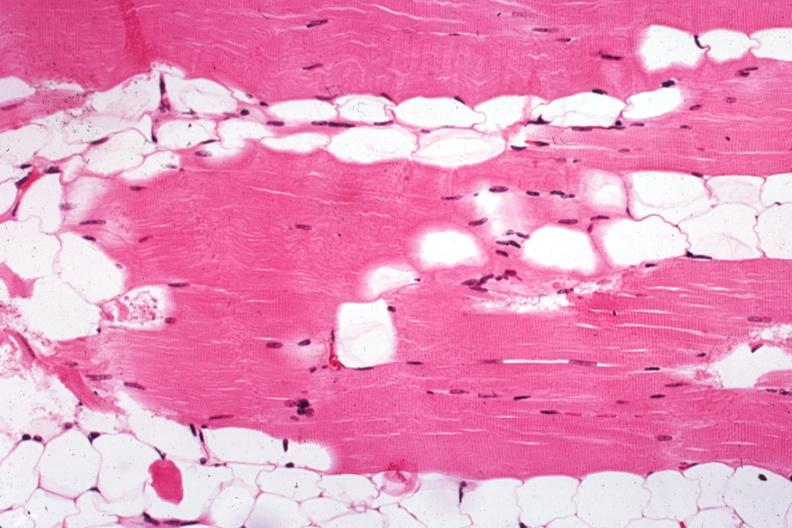what is present?
Answer the question using a single word or phrase. Soft tissue 